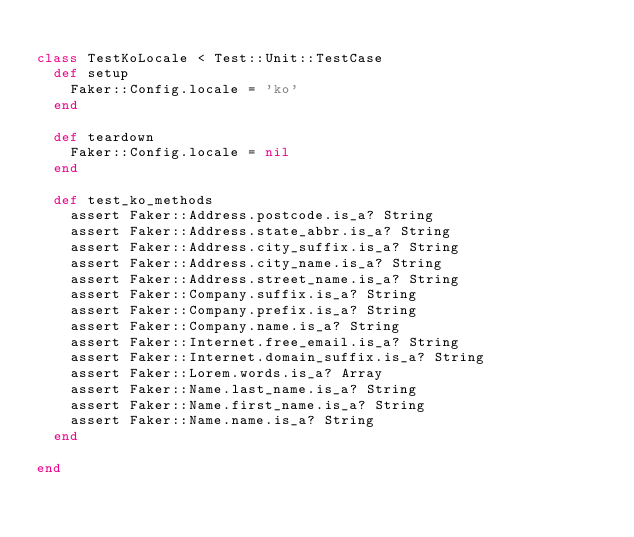Convert code to text. <code><loc_0><loc_0><loc_500><loc_500><_Ruby_>
class TestKoLocale < Test::Unit::TestCase
  def setup
    Faker::Config.locale = 'ko'
  end

  def teardown
    Faker::Config.locale = nil
  end

  def test_ko_methods
    assert Faker::Address.postcode.is_a? String
    assert Faker::Address.state_abbr.is_a? String
    assert Faker::Address.city_suffix.is_a? String
    assert Faker::Address.city_name.is_a? String
    assert Faker::Address.street_name.is_a? String
    assert Faker::Company.suffix.is_a? String
    assert Faker::Company.prefix.is_a? String
    assert Faker::Company.name.is_a? String
    assert Faker::Internet.free_email.is_a? String
    assert Faker::Internet.domain_suffix.is_a? String
    assert Faker::Lorem.words.is_a? Array
    assert Faker::Name.last_name.is_a? String
    assert Faker::Name.first_name.is_a? String
    assert Faker::Name.name.is_a? String
  end

end
</code> 